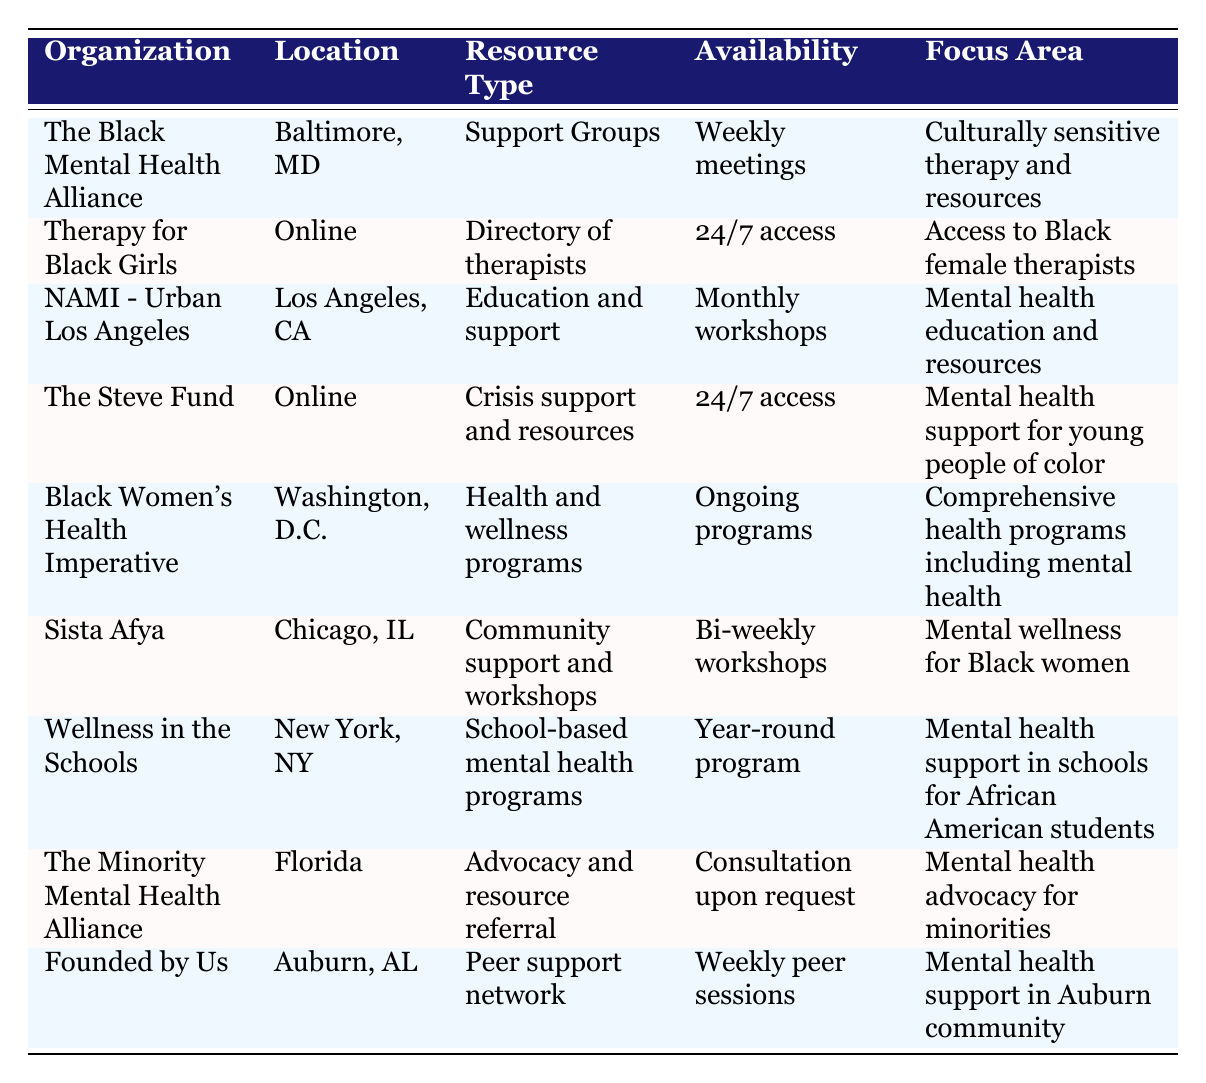What organization provides support groups and is located in Baltimore, MD? The table lists "The Black Mental Health Alliance" as the organization that provides support groups and is located in Baltimore, MD. This is directly referenced from the first row of the table.
Answer: The Black Mental Health Alliance How many organizations offer resources that are available 24/7? There are two organizations listed in the table that offer resources available 24/7: "Therapy for Black Girls" and "The Steve Fund", which can be found in their respective entries.
Answer: 2 Does "Sista Afya" focus on mental wellness for Black men? The focus area for "Sista Afya" is specifically on mental wellness for Black women as stated in the table, thus the answer is no.
Answer: No Which organization has ongoing programs related to health and wellness? According to the table, the "Black Women's Health Imperative" has ongoing programs related to health and wellness, as indicated in its entry.
Answer: Black Women's Health Imperative List the locations of organizations that offer peer support networks. The only organization listed that offers a peer support network is "Founded by Us," which is located in Auburn, AL. Therefore, the answer pertains only to this single organization’s location.
Answer: Auburn, AL What is the availability of resources offered by "NAMI (National Alliance on Mental Illness) - Urban Los Angeles"? The table indicates that resources from "NAMI - Urban Los Angeles" are available through monthly workshops, as stated in their entry.
Answer: Monthly workshops How many organizations provide resources specifically targeting young people of color? The "The Steve Fund" is the only organization mentioned that focuses specifically on mental health support for young people of color, based on the information in the table.
Answer: 1 Is there an organization that provides 24/7 access and focuses on supporting Black female therapists? Yes, "Therapy for Black Girls" provides 24/7 access and focuses on access to Black female therapists, as shown in its entry in the table.
Answer: Yes Which organization provides advocacy and resource referral, and what is their availability? The "Minority Mental Health Alliance" provides advocacy and resource referral, with availability described as consultation upon request according to the table.
Answer: Minority Mental Health Alliance; Consultation upon request How many organizations listed are located in online spaces? The table lists two organizations that operate online: "Therapy for Black Girls" and "The Steve Fund." These are clearly marked in the table under their respective locations.
Answer: 2 What is the primary focus area of "Wellness in the Schools"? The primary focus area of "Wellness in the Schools" is providing mental health support in schools specifically for African American students, as stated in the table.
Answer: Mental health support in schools for African American students 